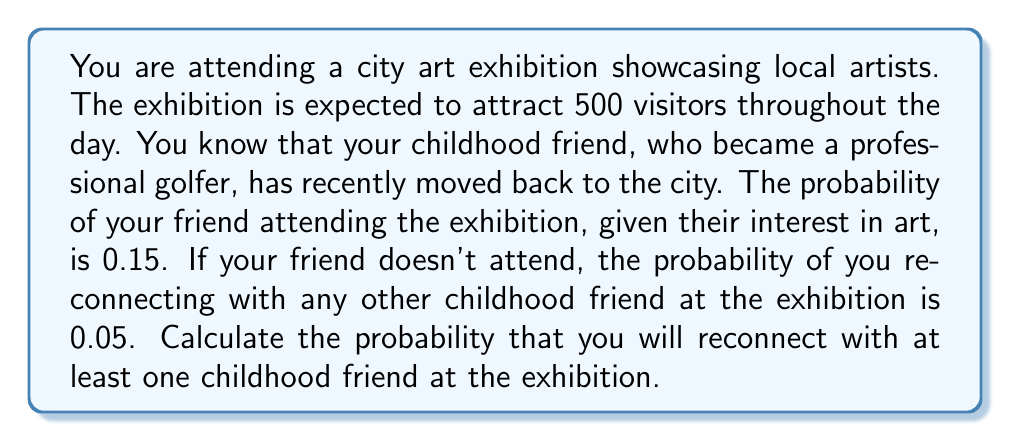Can you answer this question? Let's approach this problem using Bayesian probability:

1) Define events:
   A: Reconnecting with at least one childhood friend
   G: Your golfer friend attends the exhibition

2) We're given:
   P(G) = 0.15 (probability of golfer friend attending)
   P(A|G) = 1 (probability of reconnecting given golfer friend attends)
   P(A|not G) = 0.05 (probability of reconnecting with another friend if golfer doesn't attend)

3) We can use the law of total probability:

   $$P(A) = P(A|G) \cdot P(G) + P(A|\text{not }G) \cdot P(\text{not }G)$$

4) We know P(G) = 0.15, so P(not G) = 1 - 0.15 = 0.85

5) Substituting the values:

   $$P(A) = 1 \cdot 0.15 + 0.05 \cdot 0.85$$

6) Calculating:

   $$P(A) = 0.15 + 0.0425 = 0.1925$$

Therefore, the probability of reconnecting with at least one childhood friend at the exhibition is 0.1925 or 19.25%.
Answer: 0.1925 or 19.25% 